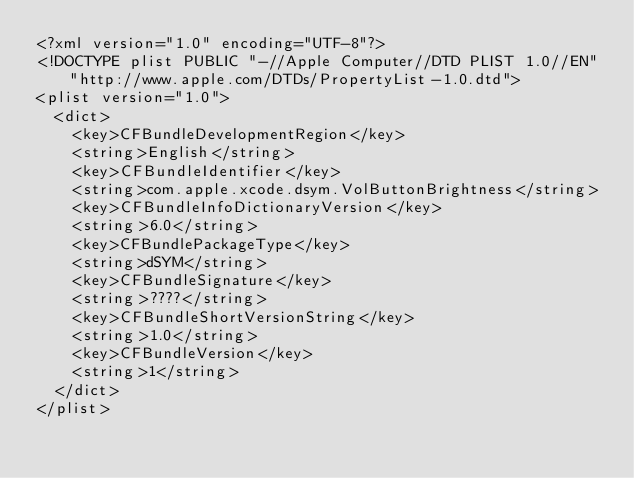<code> <loc_0><loc_0><loc_500><loc_500><_XML_><?xml version="1.0" encoding="UTF-8"?>
<!DOCTYPE plist PUBLIC "-//Apple Computer//DTD PLIST 1.0//EN" "http://www.apple.com/DTDs/PropertyList-1.0.dtd">
<plist version="1.0">
	<dict>
		<key>CFBundleDevelopmentRegion</key>
		<string>English</string>
		<key>CFBundleIdentifier</key>
		<string>com.apple.xcode.dsym.VolButtonBrightness</string>
		<key>CFBundleInfoDictionaryVersion</key>
		<string>6.0</string>
		<key>CFBundlePackageType</key>
		<string>dSYM</string>
		<key>CFBundleSignature</key>
		<string>????</string>
		<key>CFBundleShortVersionString</key>
		<string>1.0</string>
		<key>CFBundleVersion</key>
		<string>1</string>
	</dict>
</plist>
</code> 